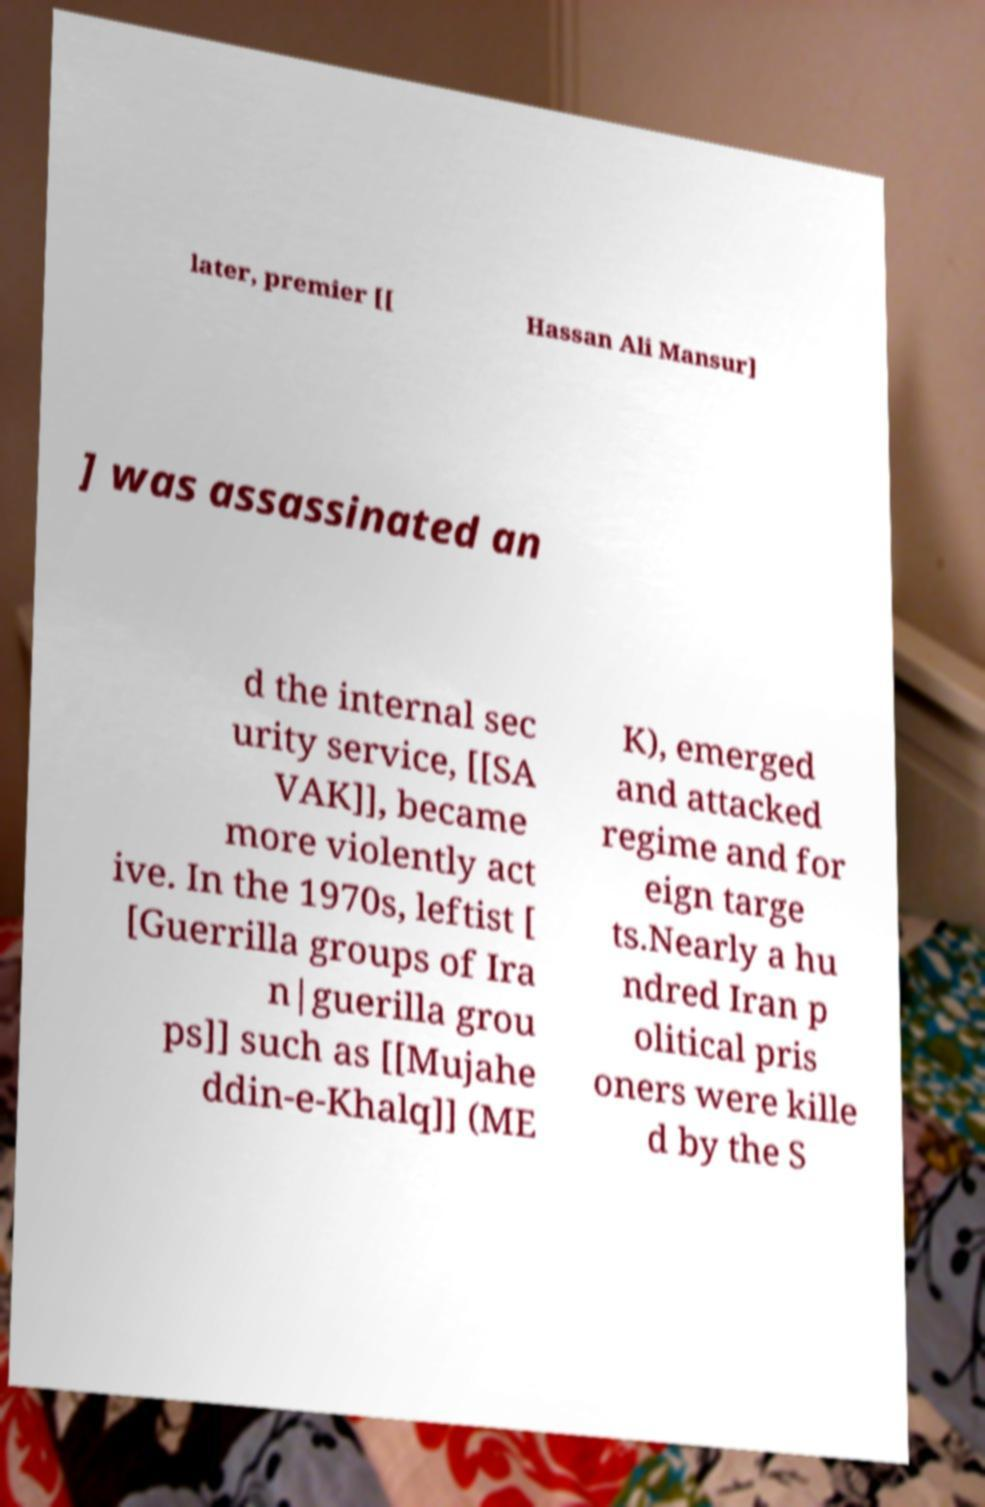Please identify and transcribe the text found in this image. later, premier [[ Hassan Ali Mansur] ] was assassinated an d the internal sec urity service, [[SA VAK]], became more violently act ive. In the 1970s, leftist [ [Guerrilla groups of Ira n|guerilla grou ps]] such as [[Mujahe ddin-e-Khalq]] (ME K), emerged and attacked regime and for eign targe ts.Nearly a hu ndred Iran p olitical pris oners were kille d by the S 